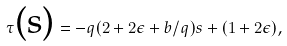<formula> <loc_0><loc_0><loc_500><loc_500>\tau \text {(s)} = - q ( 2 + 2 \epsilon + b / q ) s + ( 1 + 2 \epsilon ) ,</formula> 